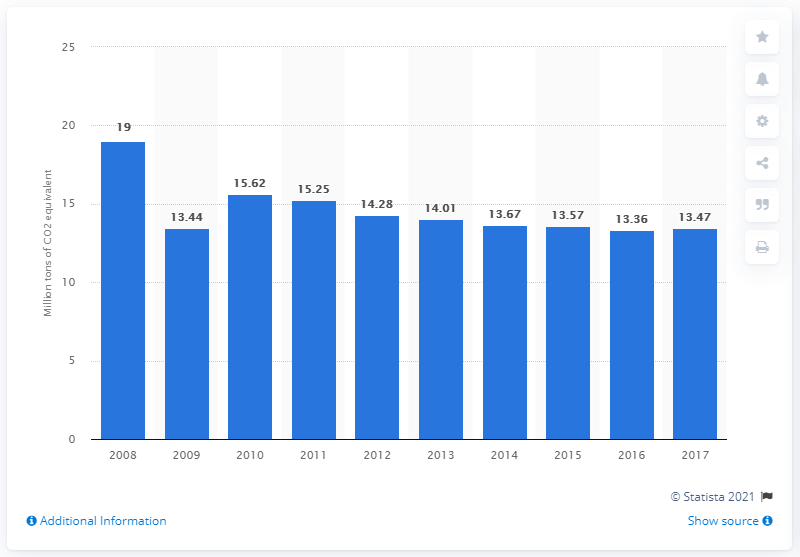How might the changes in the CO2 emission levels from 2013 to 2014 be explained? The noticeable drop in CO2 emission levels from 2013 to 2014, where emissions went from 14.28 to 14.01 million tons, could be attributed to various factors such as an increase in renewable energy adoption, improvements in energy efficiency, economic fluctuations, or shifts in industrial activity. A detailed analysis of Belgium's environmental policies and economic conditions during that period would provide a clearer explanation. 